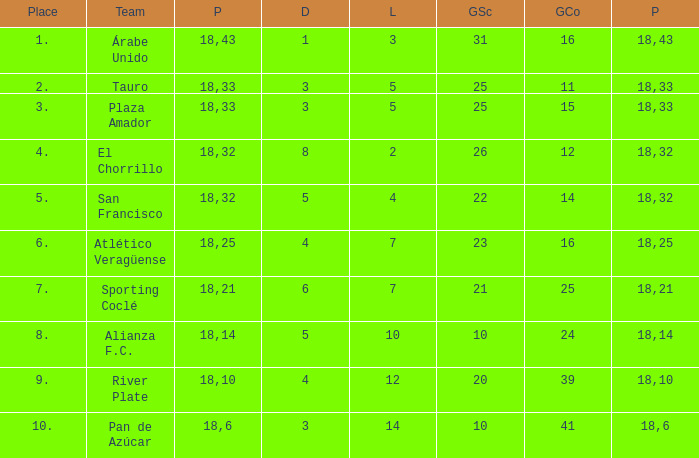Would you mind parsing the complete table? {'header': ['Place', 'Team', 'P', 'D', 'L', 'GSc', 'GCo', 'P'], 'rows': [['1.', 'Árabe Unido', '18', '1', '3', '31', '16', '43'], ['2.', 'Tauro', '18', '3', '5', '25', '11', '33'], ['3.', 'Plaza Amador', '18', '3', '5', '25', '15', '33'], ['4.', 'El Chorrillo', '18', '8', '2', '26', '12', '32'], ['5.', 'San Francisco', '18', '5', '4', '22', '14', '32'], ['6.', 'Atlético Veragüense', '18', '4', '7', '23', '16', '25'], ['7.', 'Sporting Coclé', '18', '6', '7', '21', '25', '21'], ['8.', 'Alianza F.C.', '18', '5', '10', '10', '24', '14'], ['9.', 'River Plate', '18', '4', '12', '20', '39', '10'], ['10.', 'Pan de Azúcar', '18', '3', '14', '10', '41', '6']]} How many points did the team have that conceded 41 goals and finish in a place larger than 10? 0.0. 